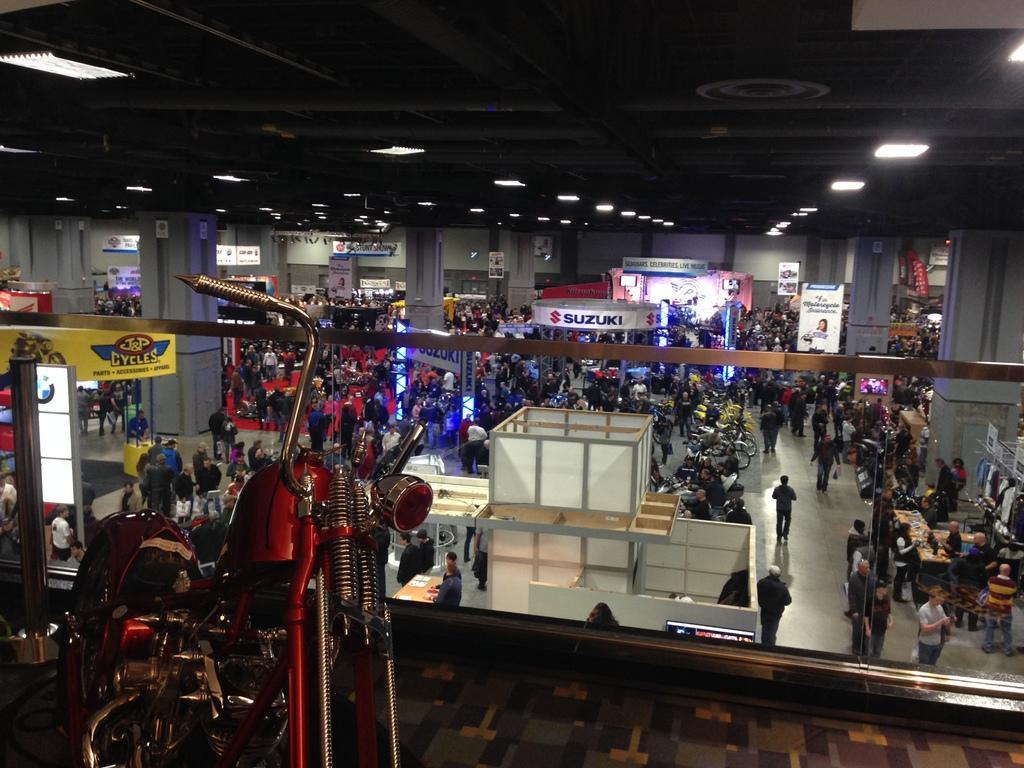Could you give a brief overview of what you see in this image? It is a bike expo, different companies and models of of the vehicles are being displayed in the hall, people are visiting all the vehicles and there is a banner of the respective company of the vehicle and there are many white lights fit to the roof. 